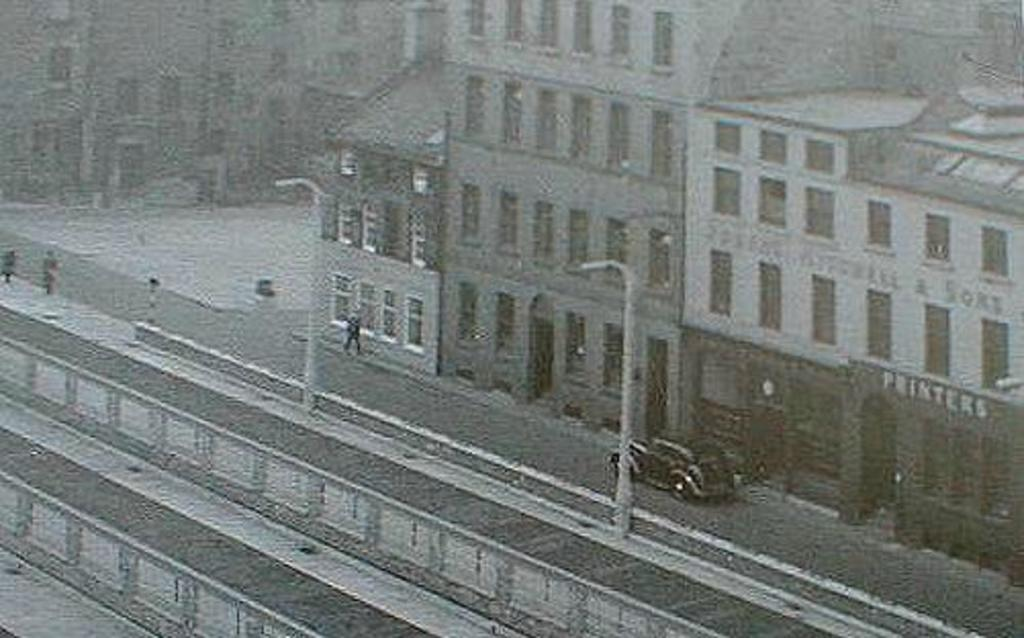What is the color scheme of the image? The image is black and white. What type of structures can be seen in the image? There are buildings in the image. What else is present in the image besides buildings? There are poles, people, vehicles, and text visible on a building. Can you tell me how many frogs are sitting on the vehicles in the image? There are no frogs present in the image; it features buildings, poles, people, and vehicles. Is there snow visible in the image? There is no snow present in the image; it is a black and white image with no indication of weather conditions. 